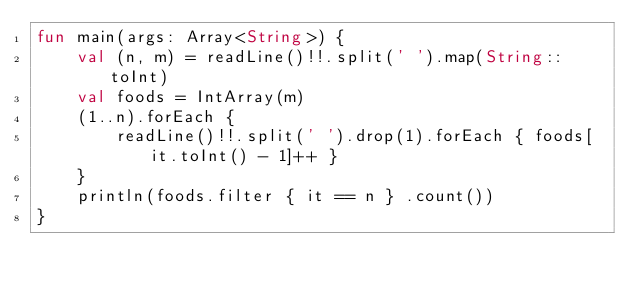<code> <loc_0><loc_0><loc_500><loc_500><_Kotlin_>fun main(args: Array<String>) {
    val (n, m) = readLine()!!.split(' ').map(String::toInt)
    val foods = IntArray(m)
    (1..n).forEach {
        readLine()!!.split(' ').drop(1).forEach { foods[it.toInt() - 1]++ }
    }
    println(foods.filter { it == n } .count())
}
</code> 